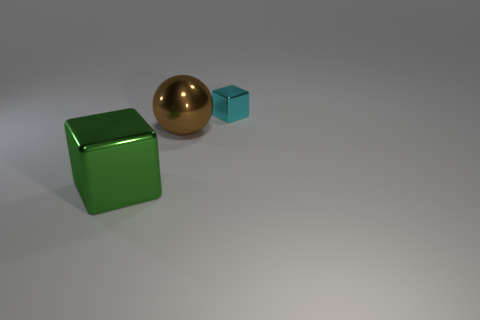Are there any other things that are the same size as the cyan object?
Your response must be concise. No. Are any small cyan objects visible?
Offer a very short reply. Yes. What number of other objects are the same size as the brown metal ball?
Your answer should be compact. 1. There is a green shiny object that is the same shape as the cyan metal thing; what size is it?
Give a very brief answer. Large. Is the material of the block behind the big green shiny cube the same as the big thing that is behind the green metal object?
Give a very brief answer. Yes. How many shiny things are either green cubes or things?
Offer a very short reply. 3. What material is the object to the right of the big thing that is to the right of the cube that is to the left of the cyan metallic object?
Ensure brevity in your answer.  Metal. There is a big metal thing behind the large green metallic thing; is it the same shape as the big metal object in front of the shiny ball?
Offer a very short reply. No. There is a metallic thing left of the large thing that is behind the large green block; what is its color?
Your response must be concise. Green. What number of cylinders are green objects or small blue matte things?
Provide a short and direct response. 0. 